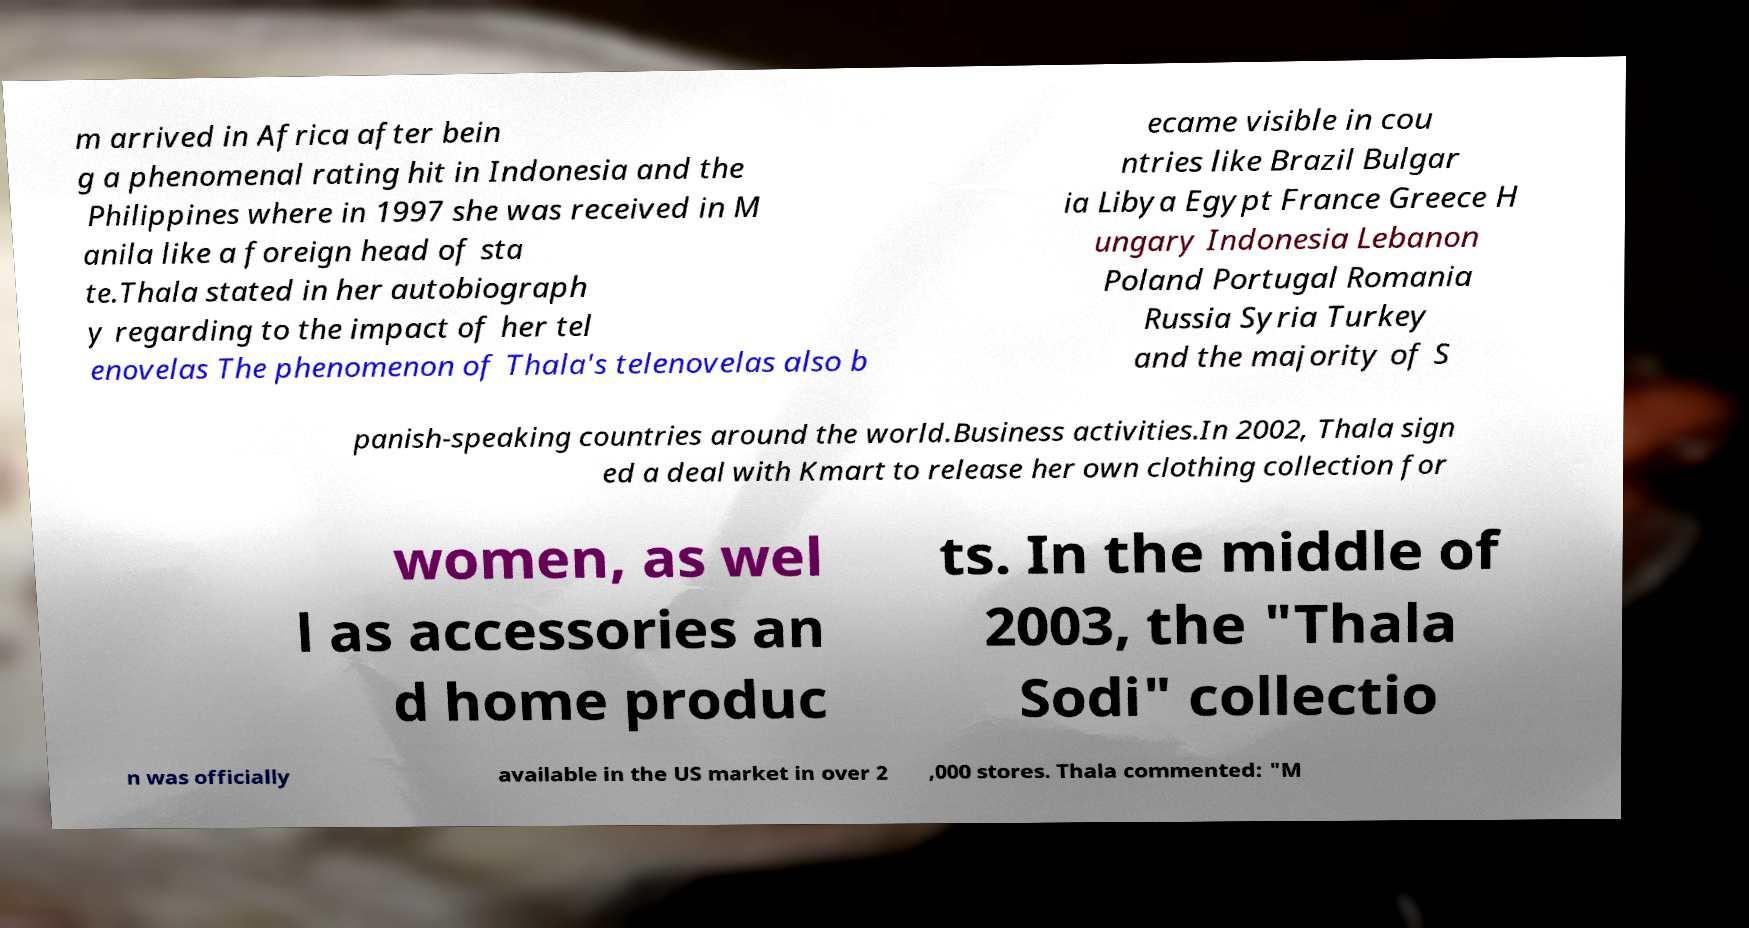Could you extract and type out the text from this image? m arrived in Africa after bein g a phenomenal rating hit in Indonesia and the Philippines where in 1997 she was received in M anila like a foreign head of sta te.Thala stated in her autobiograph y regarding to the impact of her tel enovelas The phenomenon of Thala's telenovelas also b ecame visible in cou ntries like Brazil Bulgar ia Libya Egypt France Greece H ungary Indonesia Lebanon Poland Portugal Romania Russia Syria Turkey and the majority of S panish-speaking countries around the world.Business activities.In 2002, Thala sign ed a deal with Kmart to release her own clothing collection for women, as wel l as accessories an d home produc ts. In the middle of 2003, the "Thala Sodi" collectio n was officially available in the US market in over 2 ,000 stores. Thala commented: "M 